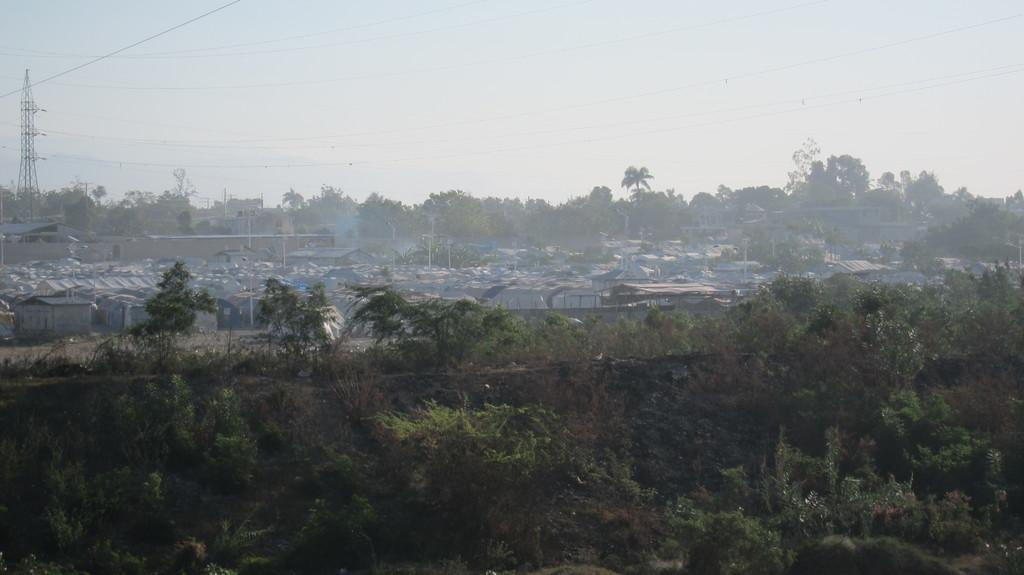What type of natural elements can be seen in the image? There are trees in the image. What type of man-made structures are present in the image? There are houses, buildings, light poles, and a tower with cables in the image. What is visible at the top of the image? The sky is visible at the top of the image. What color of ink is being used to write on the tower in the image? There is no indication of writing or ink on the tower in the image. In which direction is the wrench being used in the image? There is no wrench present in the image. 